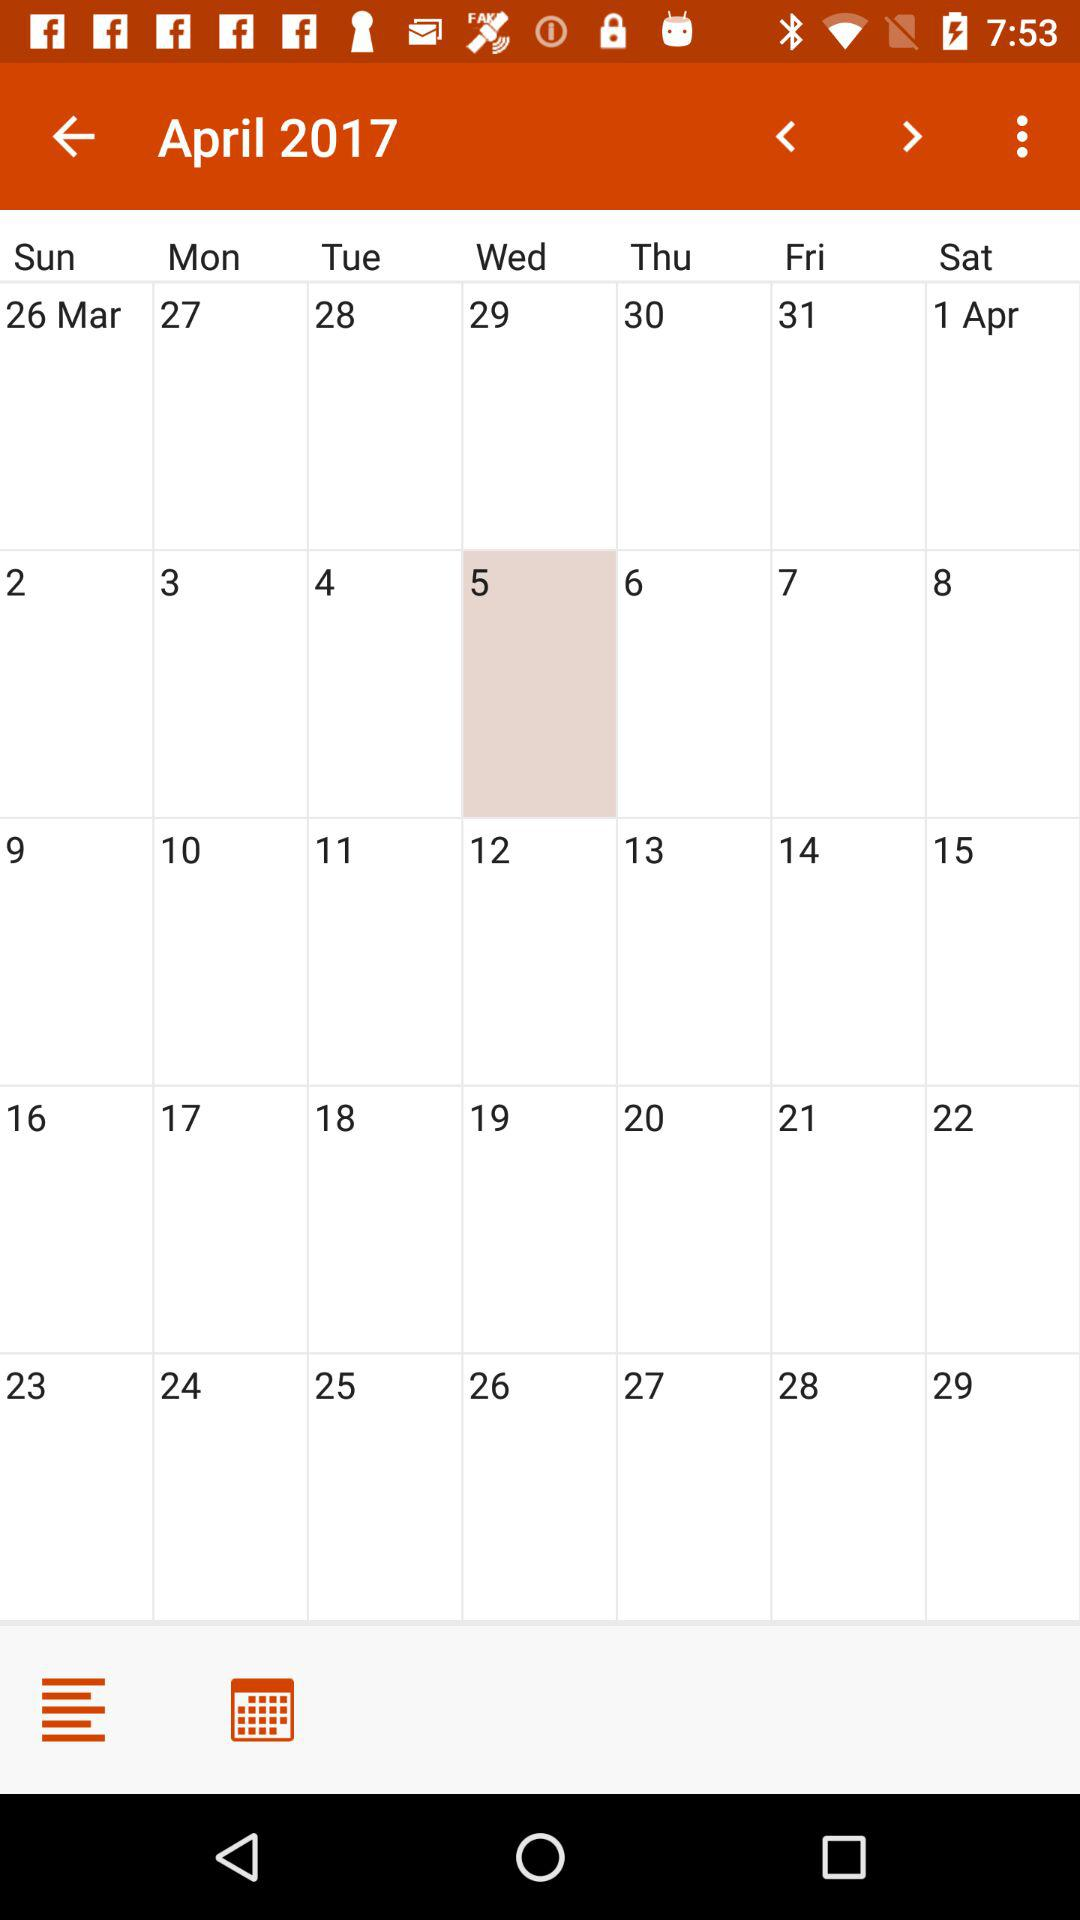What day is April 1?
Answer the question using a single word or phrase. It is Saturday. 